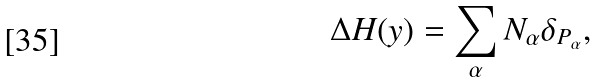Convert formula to latex. <formula><loc_0><loc_0><loc_500><loc_500>\Delta H ( y ) = \sum _ { \alpha } N _ { \alpha } \delta _ { P _ { \alpha } } ,</formula> 